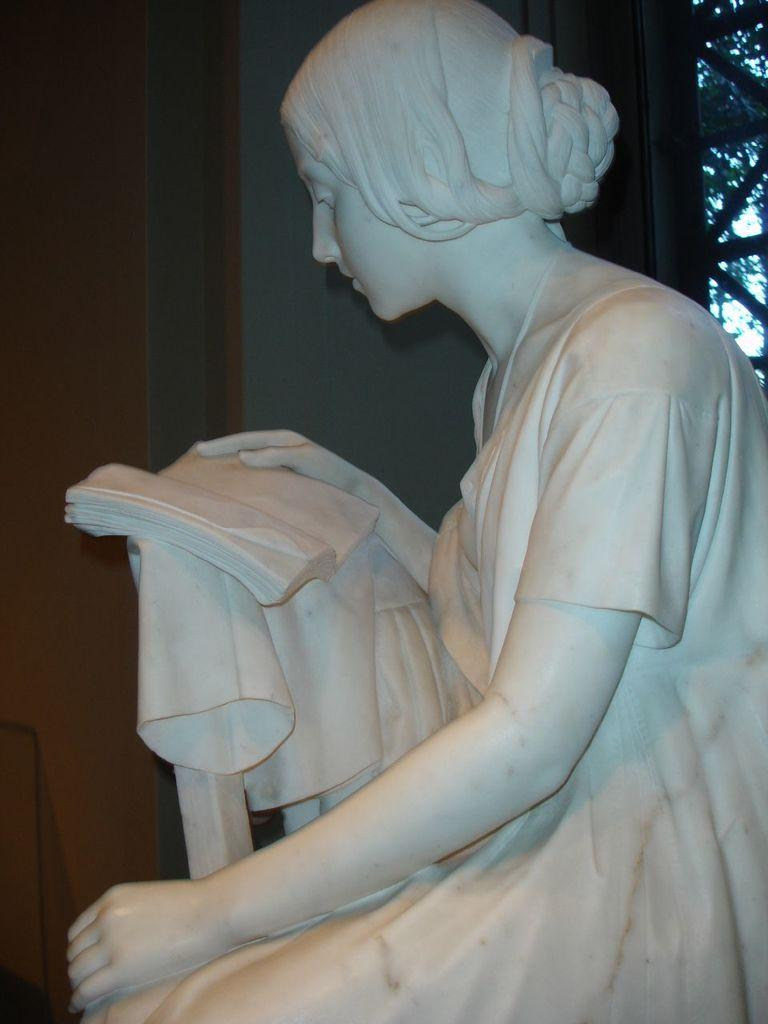What is the main subject in the image? There is a statue in the image. What can be seen in the background of the image? There are trees in the background of the image. How many drops of water can be seen falling from the machine in the image? There is no machine or water drops present in the image; it features a statue and trees in the background. 